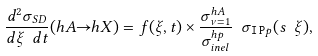Convert formula to latex. <formula><loc_0><loc_0><loc_500><loc_500>\frac { d ^ { 2 } \sigma _ { S D } } { d \xi \ d t } ( h A { \rightarrow } h X ) = f ( \xi , t ) \times \frac { \sigma ^ { h A } _ { \nu = 1 } } { \sigma ^ { h p } _ { i n e l } } \ \sigma _ { { \tt I \, P } p } ( s \ \xi ) ,</formula> 